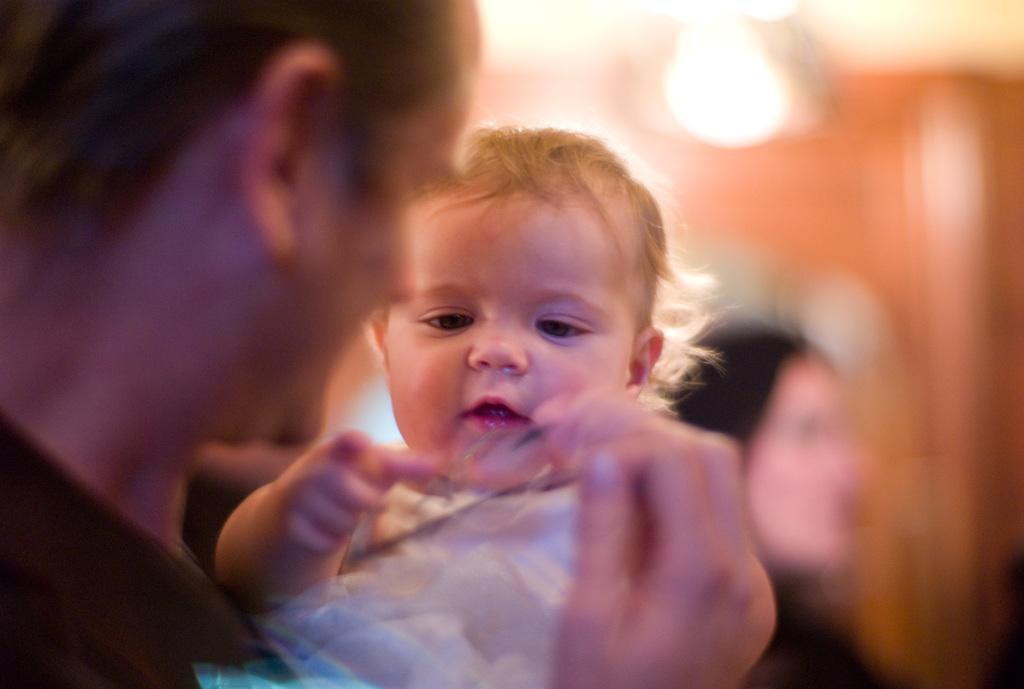Describe this image in one or two sentences. In this picture there is a person holding the baby. At the back there is a person. At the top there is a light and the image is blurry. 